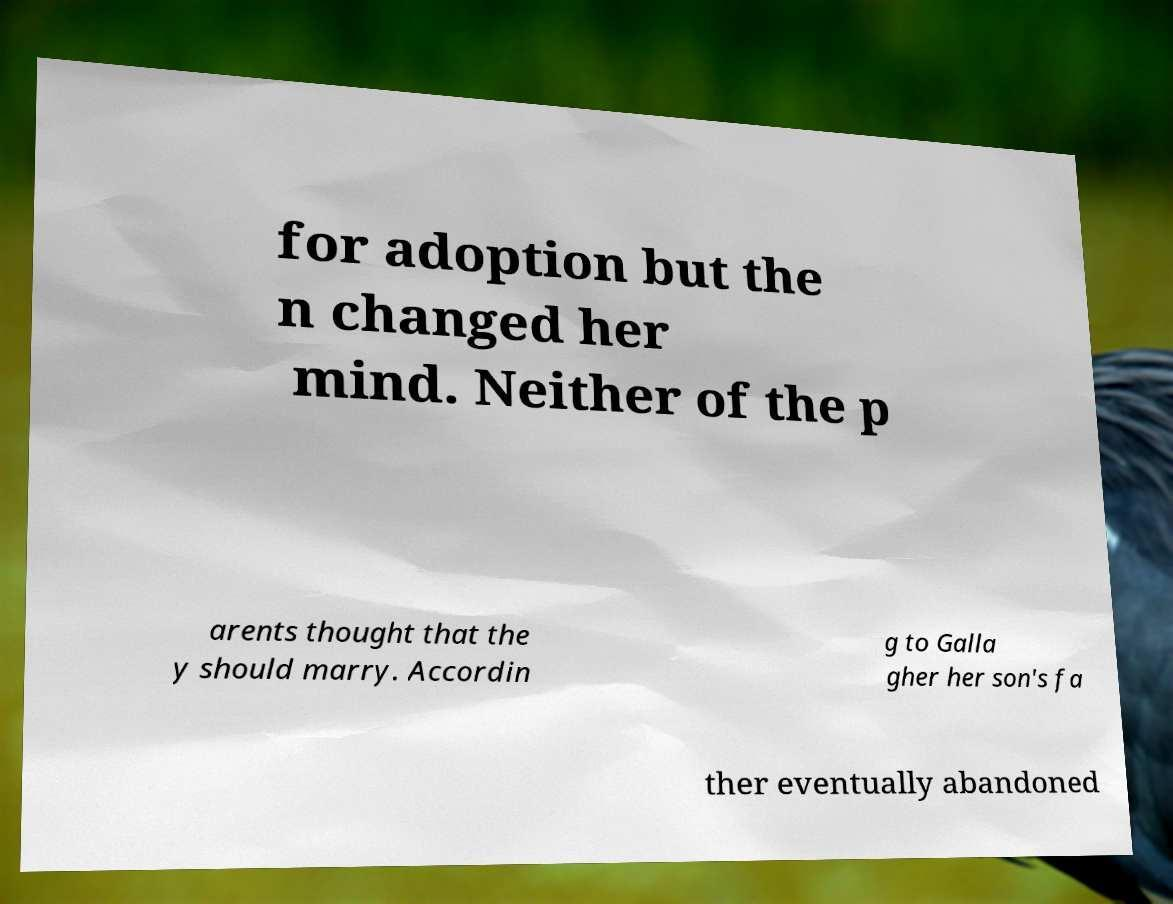I need the written content from this picture converted into text. Can you do that? for adoption but the n changed her mind. Neither of the p arents thought that the y should marry. Accordin g to Galla gher her son's fa ther eventually abandoned 